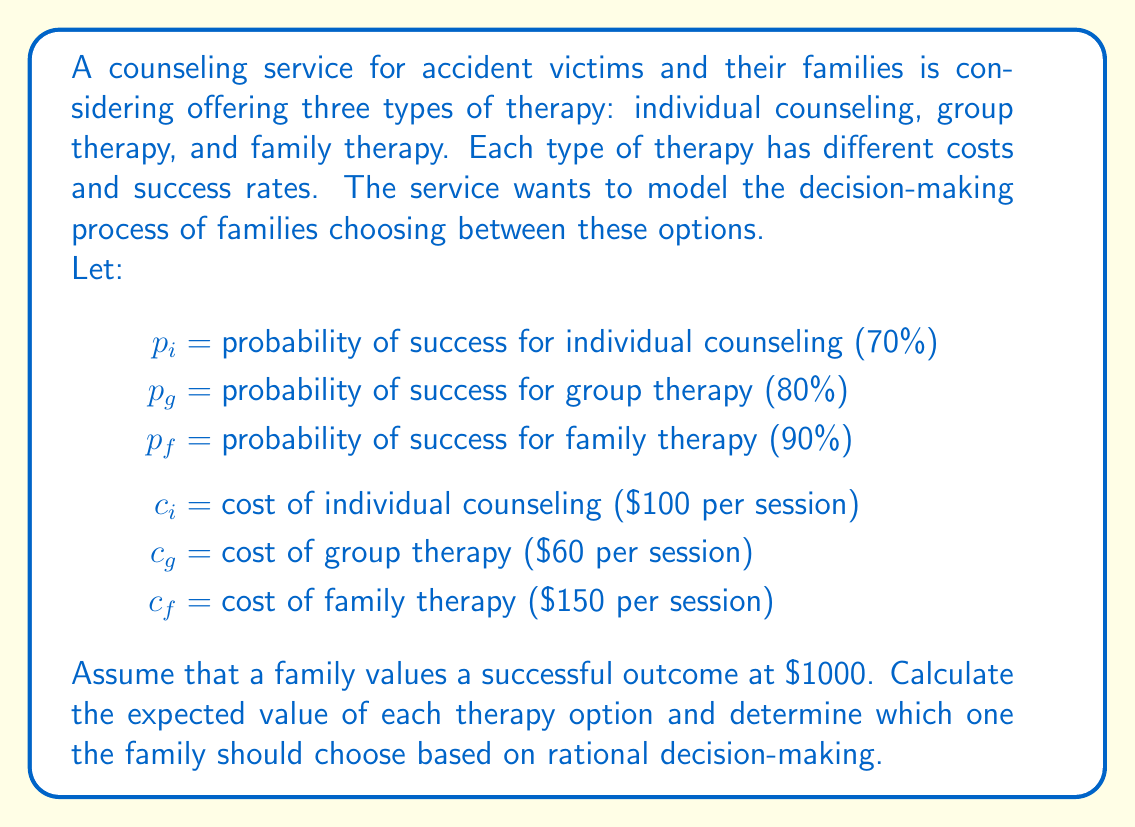Show me your answer to this math problem. To solve this problem, we need to calculate the expected value of each therapy option. The expected value is calculated by multiplying the probability of success by the value of a successful outcome, then subtracting the cost.

1. Individual Counseling:
   Expected Value = (Probability of success × Value of success) - Cost
   $$EV_i = (p_i \times 1000) - c_i$$
   $$EV_i = (0.70 \times 1000) - 100 = 600$$

2. Group Therapy:
   $$EV_g = (p_g \times 1000) - c_g$$
   $$EV_g = (0.80 \times 1000) - 60 = 740$$

3. Family Therapy:
   $$EV_f = (p_f \times 1000) - c_f$$
   $$EV_f = (0.90 \times 1000) - 150 = 750$$

Now, we compare the expected values:

Individual Counseling: $600
Group Therapy: $740
Family Therapy: $750

The option with the highest expected value is the most rational choice for the family.
Answer: Based on the expected value calculations, the family should choose family therapy, which has the highest expected value of $750. 